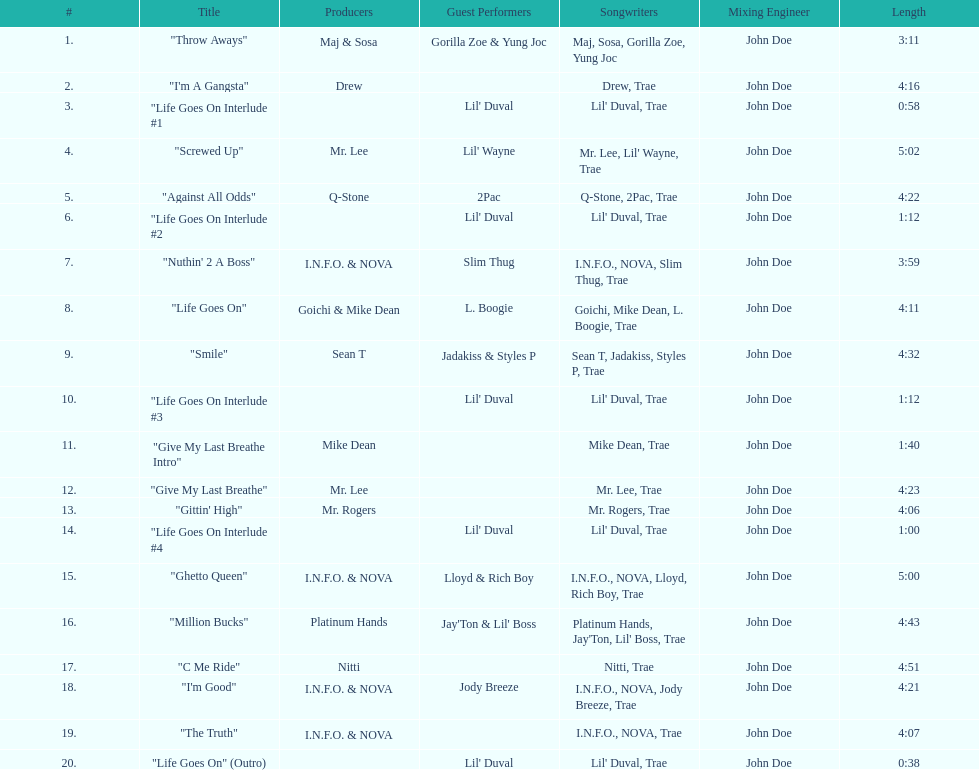What is the last track produced by mr. lee? "Give My Last Breathe". Could you help me parse every detail presented in this table? {'header': ['#', 'Title', 'Producers', 'Guest Performers', 'Songwriters', 'Mixing Engineer', 'Length'], 'rows': [['1.', '"Throw Aways"', 'Maj & Sosa', 'Gorilla Zoe & Yung Joc', 'Maj, Sosa, Gorilla Zoe, Yung Joc', 'John Doe', '3:11'], ['2.', '"I\'m A Gangsta"', 'Drew', '', 'Drew, Trae', 'John Doe', '4:16'], ['3.', '"Life Goes On Interlude #1', '', "Lil' Duval", "Lil' Duval, Trae", 'John Doe', '0:58'], ['4.', '"Screwed Up"', 'Mr. Lee', "Lil' Wayne", "Mr. Lee, Lil' Wayne, Trae", 'John Doe', '5:02'], ['5.', '"Against All Odds"', 'Q-Stone', '2Pac', 'Q-Stone, 2Pac, Trae', 'John Doe', '4:22'], ['6.', '"Life Goes On Interlude #2', '', "Lil' Duval", "Lil' Duval, Trae", 'John Doe', '1:12'], ['7.', '"Nuthin\' 2 A Boss"', 'I.N.F.O. & NOVA', 'Slim Thug', 'I.N.F.O., NOVA, Slim Thug, Trae', 'John Doe', '3:59'], ['8.', '"Life Goes On"', 'Goichi & Mike Dean', 'L. Boogie', 'Goichi, Mike Dean, L. Boogie, Trae', 'John Doe', '4:11'], ['9.', '"Smile"', 'Sean T', 'Jadakiss & Styles P', 'Sean T, Jadakiss, Styles P, Trae', 'John Doe', '4:32'], ['10.', '"Life Goes On Interlude #3', '', "Lil' Duval", "Lil' Duval, Trae", 'John Doe', '1:12'], ['11.', '"Give My Last Breathe Intro"', 'Mike Dean', '', 'Mike Dean, Trae', 'John Doe', '1:40'], ['12.', '"Give My Last Breathe"', 'Mr. Lee', '', 'Mr. Lee, Trae', 'John Doe', '4:23'], ['13.', '"Gittin\' High"', 'Mr. Rogers', '', 'Mr. Rogers, Trae', 'John Doe', '4:06'], ['14.', '"Life Goes On Interlude #4', '', "Lil' Duval", "Lil' Duval, Trae", 'John Doe', '1:00'], ['15.', '"Ghetto Queen"', 'I.N.F.O. & NOVA', 'Lloyd & Rich Boy', 'I.N.F.O., NOVA, Lloyd, Rich Boy, Trae', 'John Doe', '5:00'], ['16.', '"Million Bucks"', 'Platinum Hands', "Jay'Ton & Lil' Boss", "Platinum Hands, Jay'Ton, Lil' Boss, Trae", 'John Doe', '4:43'], ['17.', '"C Me Ride"', 'Nitti', '', 'Nitti, Trae', 'John Doe', '4:51'], ['18.', '"I\'m Good"', 'I.N.F.O. & NOVA', 'Jody Breeze', 'I.N.F.O., NOVA, Jody Breeze, Trae', 'John Doe', '4:21'], ['19.', '"The Truth"', 'I.N.F.O. & NOVA', '', 'I.N.F.O., NOVA, Trae', 'John Doe', '4:07'], ['20.', '"Life Goes On" (Outro)', '', "Lil' Duval", "Lil' Duval, Trae", 'John Doe', '0:38']]} 